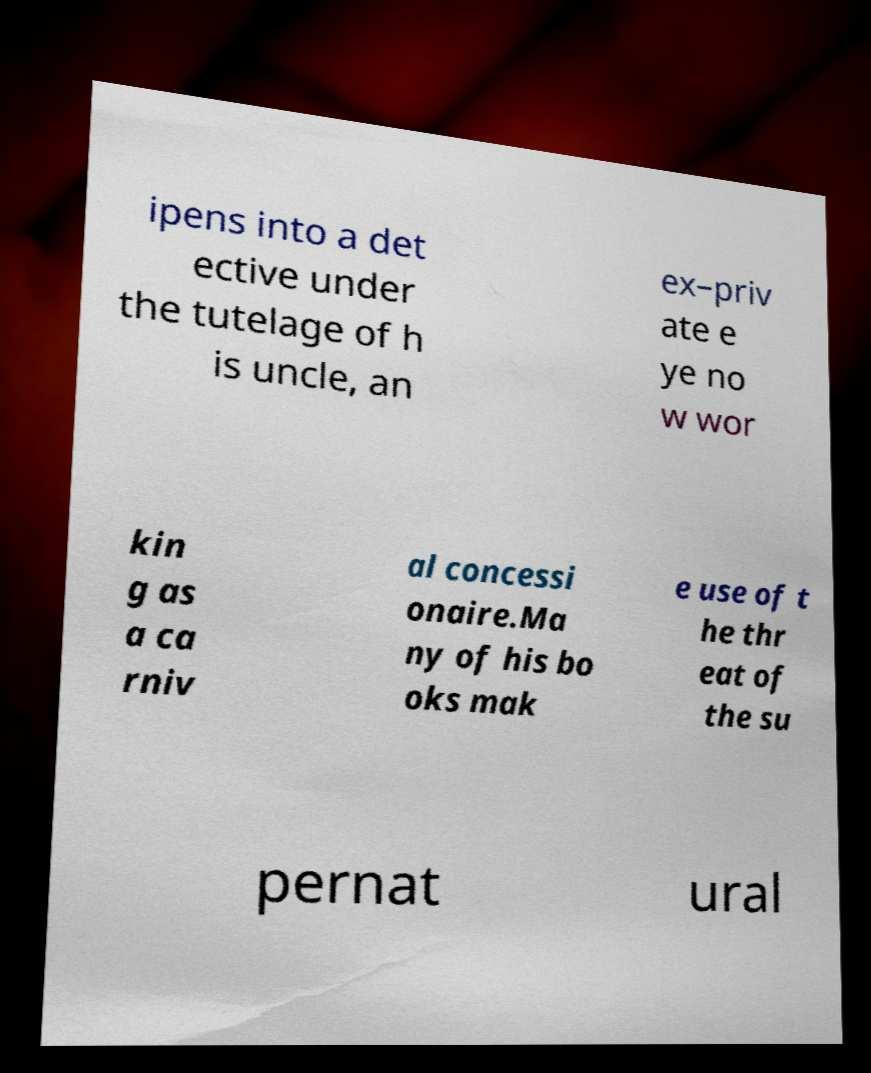Please identify and transcribe the text found in this image. ipens into a det ective under the tutelage of h is uncle, an ex–priv ate e ye no w wor kin g as a ca rniv al concessi onaire.Ma ny of his bo oks mak e use of t he thr eat of the su pernat ural 